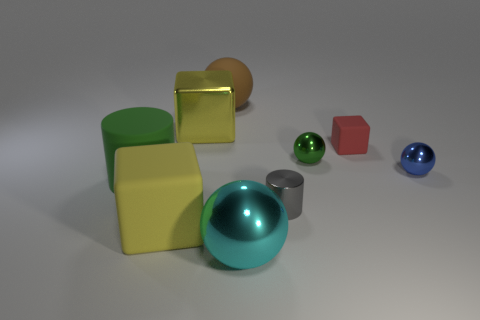There is a cyan sphere that is the same size as the matte cylinder; what is its material?
Your response must be concise. Metal. What is the shape of the yellow object that is behind the tiny blue shiny sphere that is right of the small metallic object that is behind the tiny blue sphere?
Your response must be concise. Cube. What is the shape of the yellow matte thing that is the same size as the green cylinder?
Offer a terse response. Cube. How many tiny green metal things are to the left of the yellow block in front of the big object that is to the left of the yellow matte block?
Your response must be concise. 0. Are there more gray objects that are in front of the big yellow matte thing than small cylinders that are behind the green rubber cylinder?
Offer a terse response. No. How many metal things have the same shape as the red rubber object?
Your answer should be compact. 1. What number of objects are big shiny things that are in front of the big yellow metal block or objects to the right of the green shiny thing?
Your response must be concise. 3. What is the material of the yellow cube left of the yellow block that is right of the big yellow object in front of the big metal block?
Your response must be concise. Rubber. There is a big metallic object behind the large rubber block; is its color the same as the large metallic ball?
Keep it short and to the point. No. What material is the cube that is both in front of the yellow metallic block and on the left side of the gray metal thing?
Give a very brief answer. Rubber. 